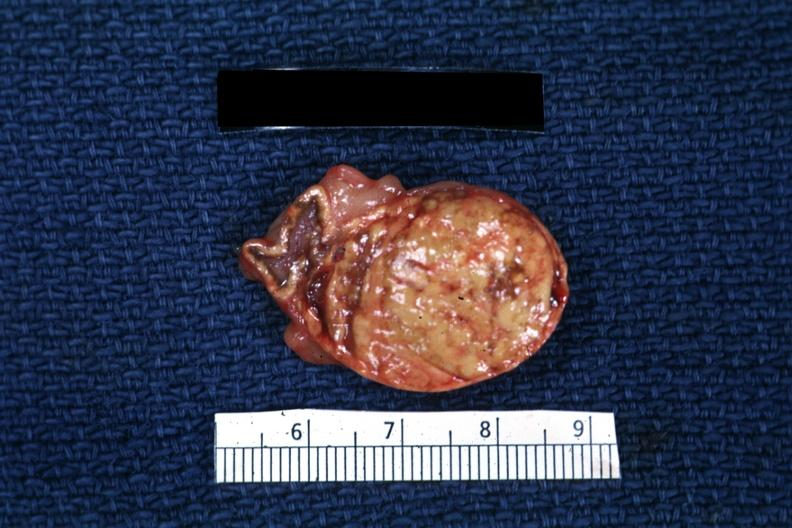does this image show typical cortical nodule?
Answer the question using a single word or phrase. Yes 